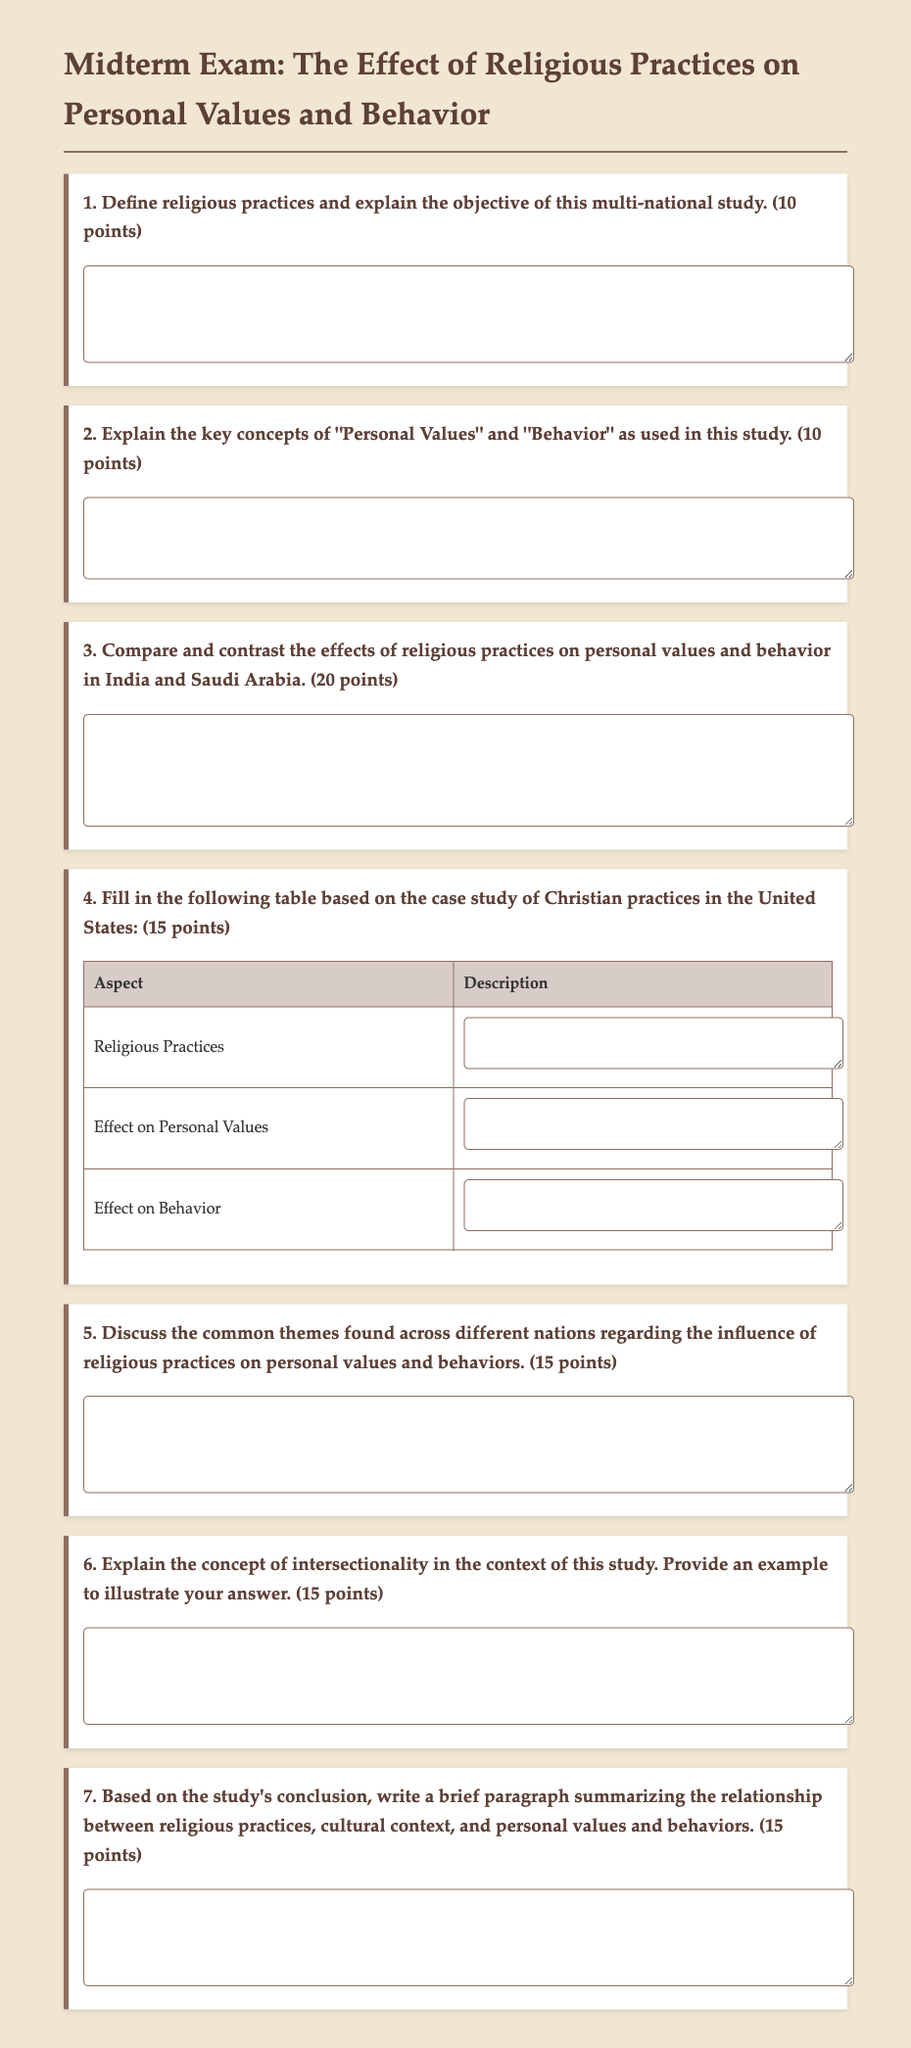What is the title of the midterm exam? The title of the midterm exam is given in the document header under the main heading.
Answer: The Effect of Religious Practices on Personal Values and Behavior: A Multi-National Study How many points is question 1 worth? The point value is specified next to each question in the document.
Answer: 10 points What is asked in question 4 of the exam? The content of question 4, including its focus on a specific case study, is outlined in the document.
Answer: Fill in the following table based on the case study of Christian practices in the United States What is the maximum width of the content area in the document? The maximum width for the content area is described within the styling information of the document.
Answer: 800px Which question asks for a discussion on common themes across different nations? The phrasing of question 5 indicates that it inquires about similarities in religious practices and their influence across countries.
Answer: Discuss the common themes found across different nations regarding the influence of religious practices on personal values and behaviors What aspect of the study does question 6 inquire about? Question 6 focuses on a specific concept pertinent to how different identities intersect in relation to the study's findings.
Answer: Explain the concept of intersectionality in the context of this study What are the two key concepts defined in question 2? The key concepts are identified within the context of the document's instruction to define them.
Answer: Personal Values and Behavior 